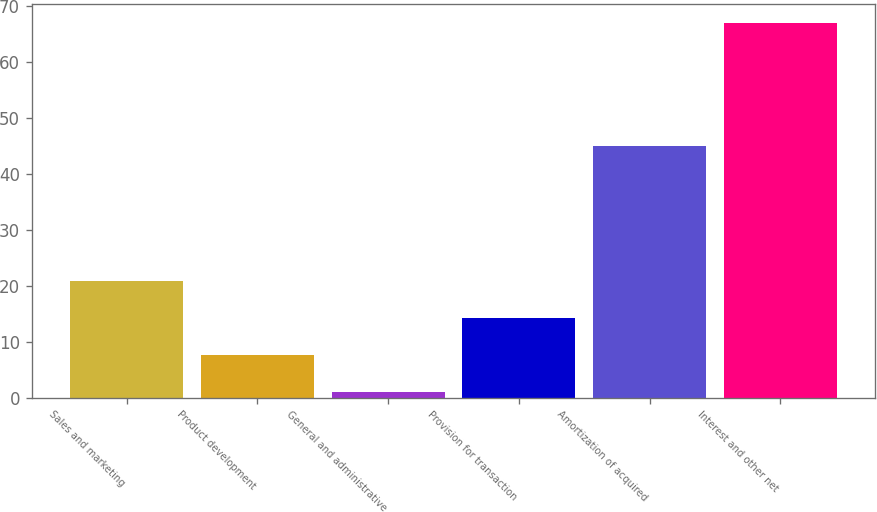Convert chart to OTSL. <chart><loc_0><loc_0><loc_500><loc_500><bar_chart><fcel>Sales and marketing<fcel>Product development<fcel>General and administrative<fcel>Provision for transaction<fcel>Amortization of acquired<fcel>Interest and other net<nl><fcel>20.8<fcel>7.6<fcel>1<fcel>14.2<fcel>45<fcel>67<nl></chart> 